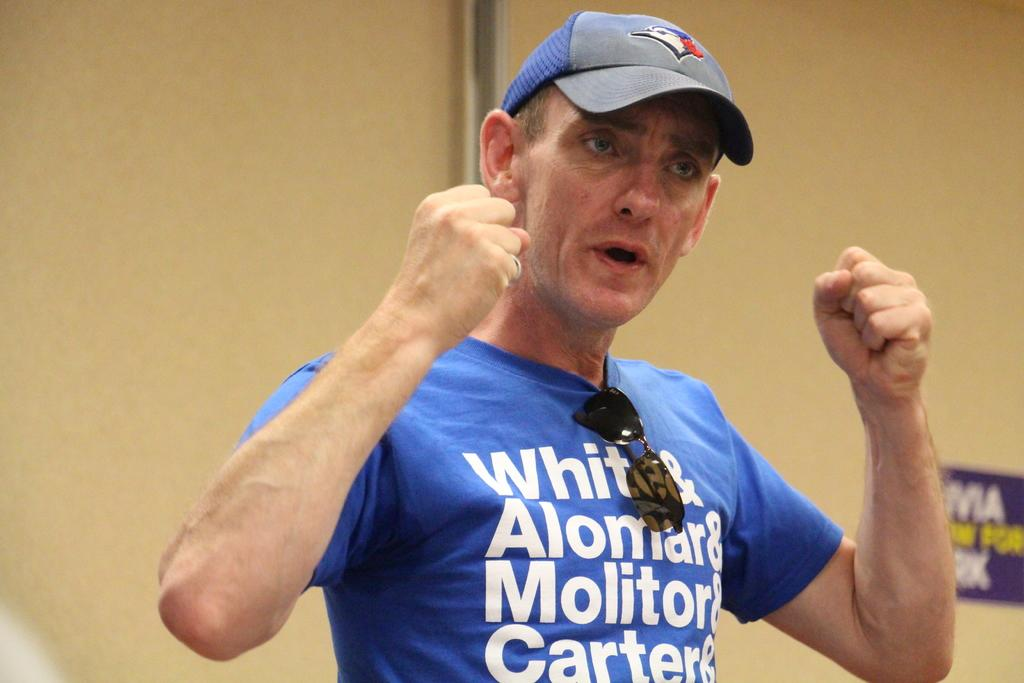<image>
Write a terse but informative summary of the picture. a person wearing a blue shirt that says carter on it 